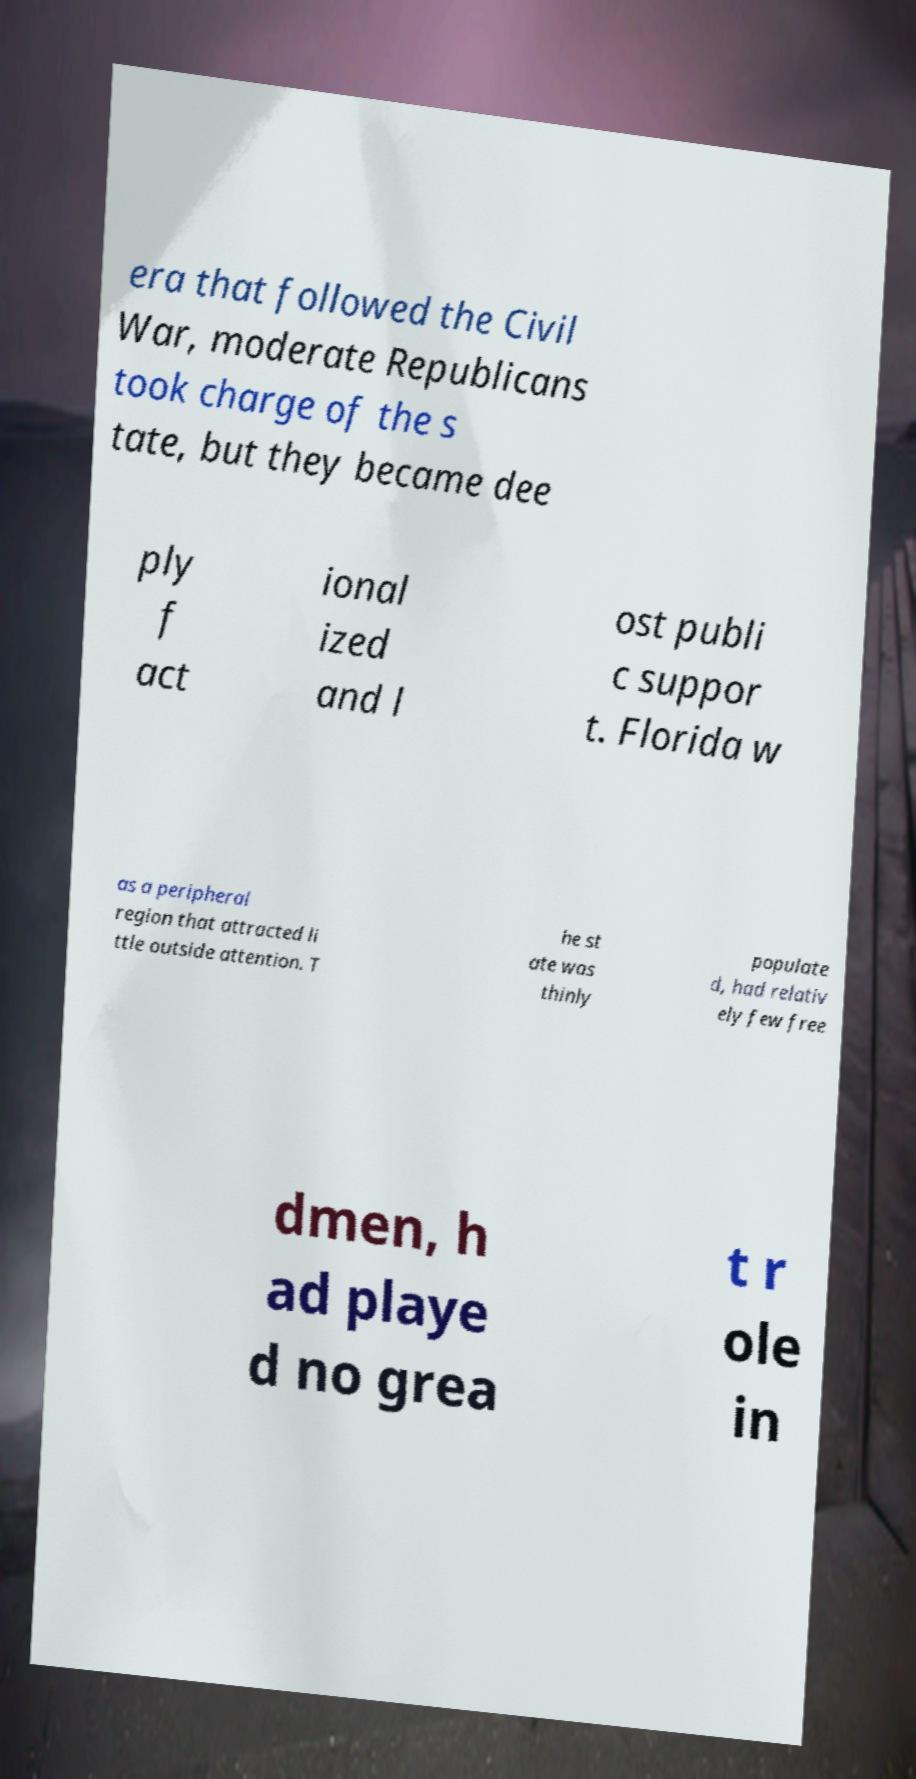Please identify and transcribe the text found in this image. era that followed the Civil War, moderate Republicans took charge of the s tate, but they became dee ply f act ional ized and l ost publi c suppor t. Florida w as a peripheral region that attracted li ttle outside attention. T he st ate was thinly populate d, had relativ ely few free dmen, h ad playe d no grea t r ole in 